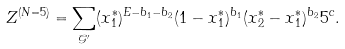Convert formula to latex. <formula><loc_0><loc_0><loc_500><loc_500>Z ^ { ( N = 5 ) } = \sum _ { \mathcal { G ^ { \prime } } } ( x _ { 1 } ^ { * } ) ^ { E - b _ { 1 } - b _ { 2 } } ( 1 - x _ { 1 } ^ { * } ) ^ { b _ { 1 } } ( x _ { 2 } ^ { * } - x _ { 1 } ^ { * } ) ^ { b _ { 2 } } 5 ^ { c } .</formula> 